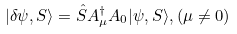Convert formula to latex. <formula><loc_0><loc_0><loc_500><loc_500>| \delta \psi , S \rangle = \hat { S } A ^ { \dag } _ { \mu } A _ { 0 } | \psi , S \rangle , ( \mu \neq 0 )</formula> 